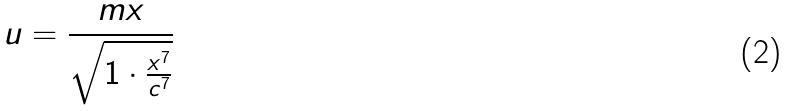Convert formula to latex. <formula><loc_0><loc_0><loc_500><loc_500>u = \frac { m x } { \sqrt { 1 \cdot \frac { x ^ { 7 } } { c ^ { 7 } } } }</formula> 